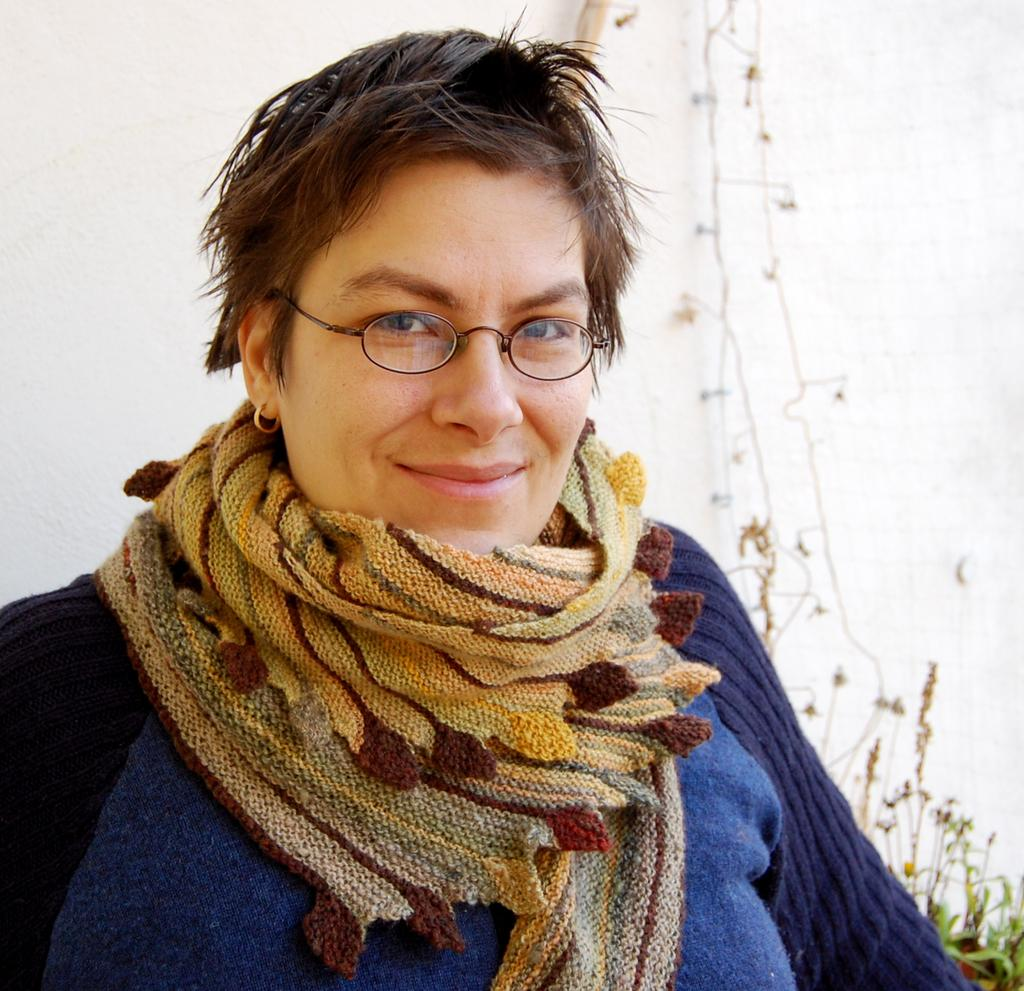What is present in the image? There is a person in the image. What can be seen in the background of the image? There are plants and a wall in the background of the image. What type of clock is hanging on the wall in the image? There is no clock visible in the image. What type of business is being conducted by the person in the image? There is no indication of any business activity in the image. 